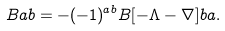<formula> <loc_0><loc_0><loc_500><loc_500>\L B { a } { b } = - ( - 1 ) ^ { a b } \L B [ - \Lambda - \nabla ] { b } { a } .</formula> 